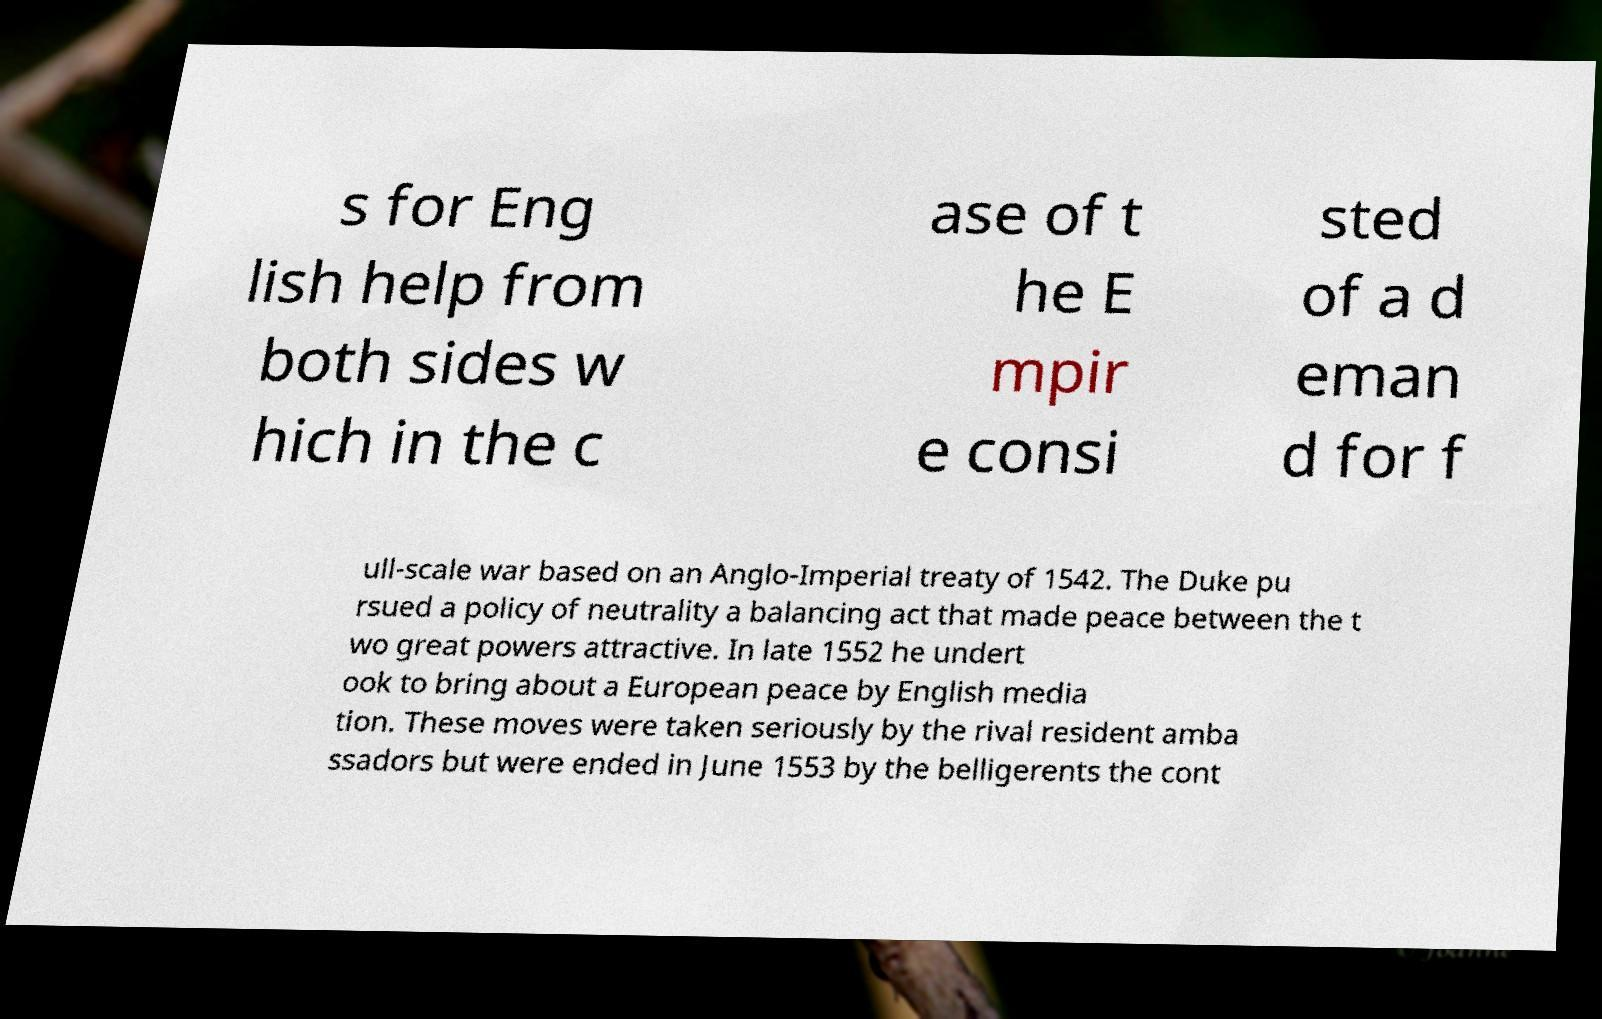What messages or text are displayed in this image? I need them in a readable, typed format. s for Eng lish help from both sides w hich in the c ase of t he E mpir e consi sted of a d eman d for f ull-scale war based on an Anglo-Imperial treaty of 1542. The Duke pu rsued a policy of neutrality a balancing act that made peace between the t wo great powers attractive. In late 1552 he undert ook to bring about a European peace by English media tion. These moves were taken seriously by the rival resident amba ssadors but were ended in June 1553 by the belligerents the cont 